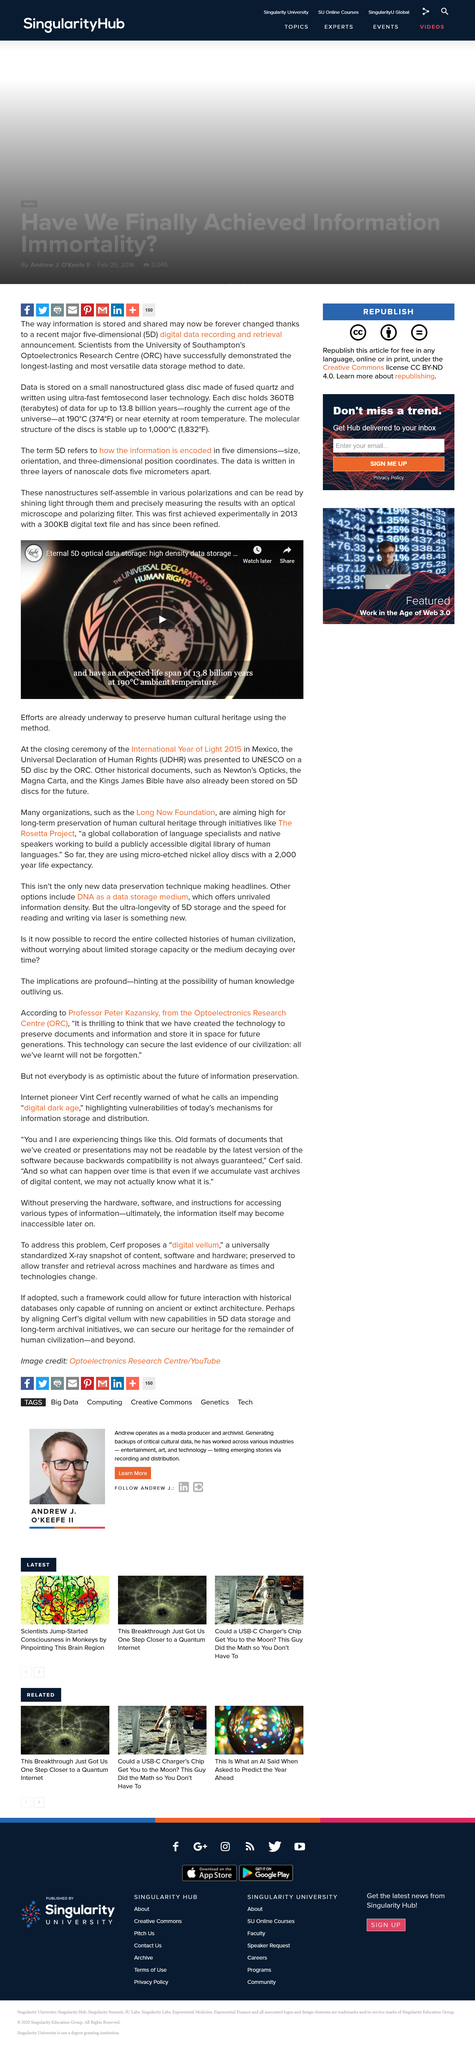Specify some key components in this picture. The molecular structure of the discs is stable up to 1,000°C. Each disc can store a maximum of 360 terabytes of data. The acronym "ORC" in this article refers to Optoelectronics Research Centre. 